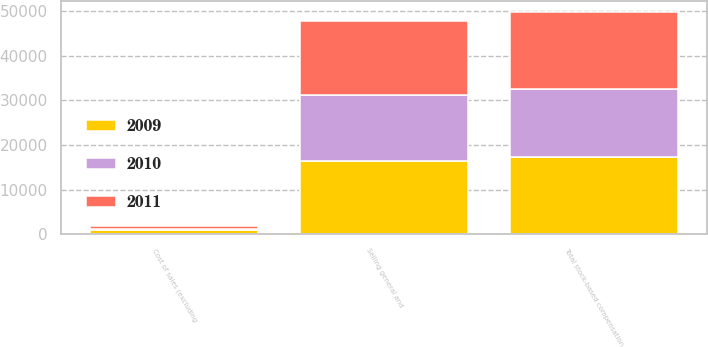Convert chart. <chart><loc_0><loc_0><loc_500><loc_500><stacked_bar_chart><ecel><fcel>Cost of sales (excluding<fcel>Selling general and<fcel>Total stock-based compensation<nl><fcel>2010<fcel>248<fcel>14962<fcel>15210<nl><fcel>2011<fcel>730<fcel>16544<fcel>17274<nl><fcel>2009<fcel>914<fcel>16336<fcel>17250<nl></chart> 